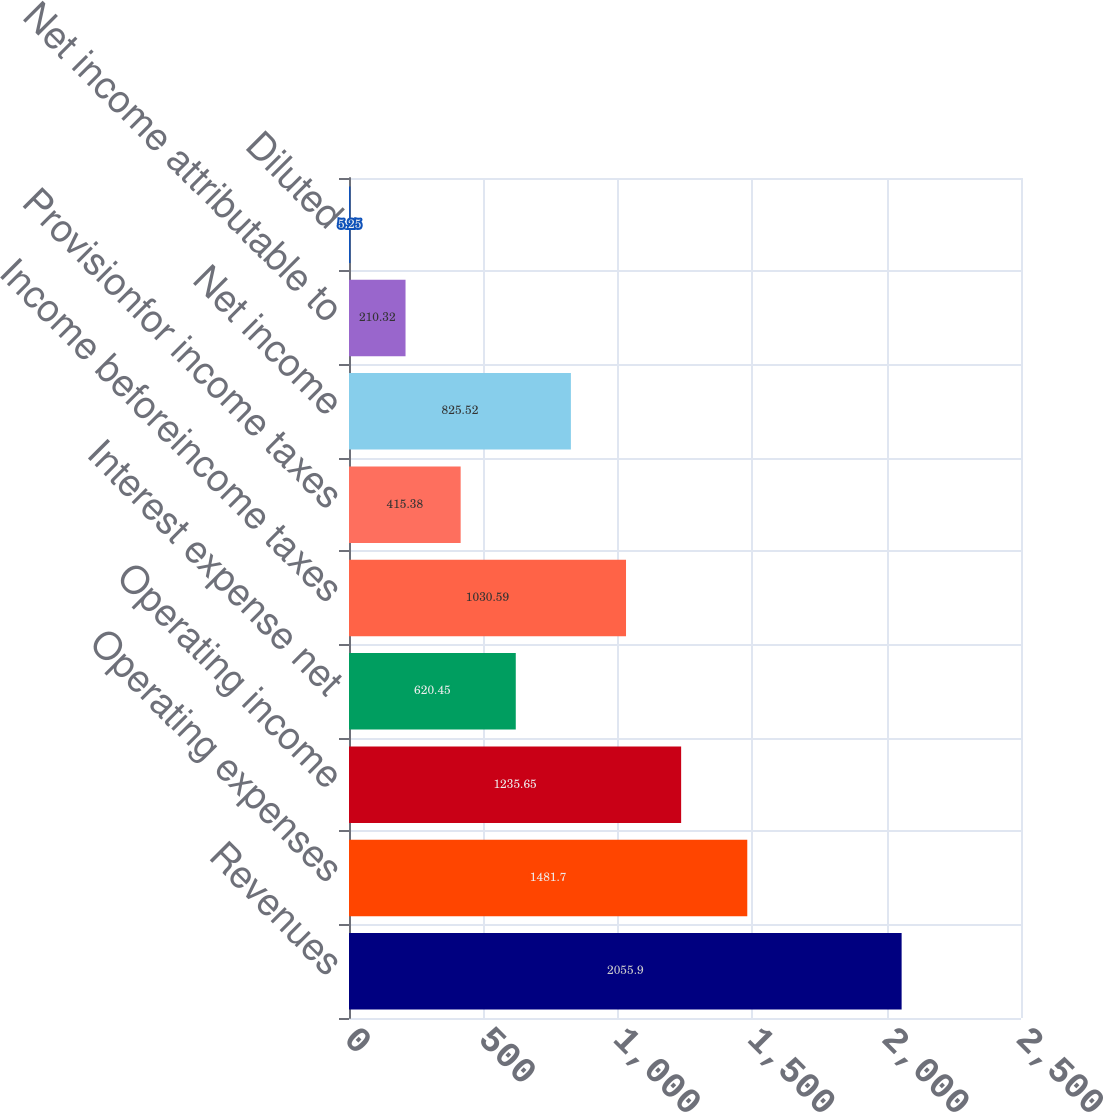Convert chart. <chart><loc_0><loc_0><loc_500><loc_500><bar_chart><fcel>Revenues<fcel>Operating expenses<fcel>Operating income<fcel>Interest expense net<fcel>Income beforeincome taxes<fcel>Provisionfor income taxes<fcel>Net income<fcel>Net income attributable to<fcel>Diluted<nl><fcel>2055.9<fcel>1481.7<fcel>1235.65<fcel>620.45<fcel>1030.59<fcel>415.38<fcel>825.52<fcel>210.32<fcel>5.25<nl></chart> 